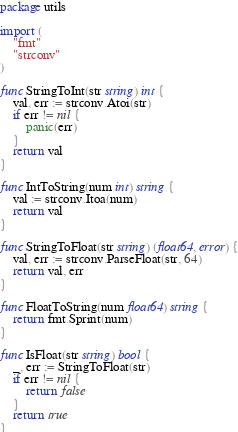Convert code to text. <code><loc_0><loc_0><loc_500><loc_500><_Go_>package utils

import (
	"fmt"
	"strconv"
)

func StringToInt(str string) int {
	val, err := strconv.Atoi(str)
	if err != nil {
		panic(err)
	}
	return val
}

func IntToString(num int) string {
	val := strconv.Itoa(num)
	return val
}

func StringToFloat(str string) (float64, error) {
	val, err := strconv.ParseFloat(str, 64)
	return val, err
}

func FloatToString(num float64) string {
	return fmt.Sprint(num)
}

func IsFloat(str string) bool {
	_, err := StringToFloat(str)
	if err != nil {
		return false
	}
	return true
}
</code> 